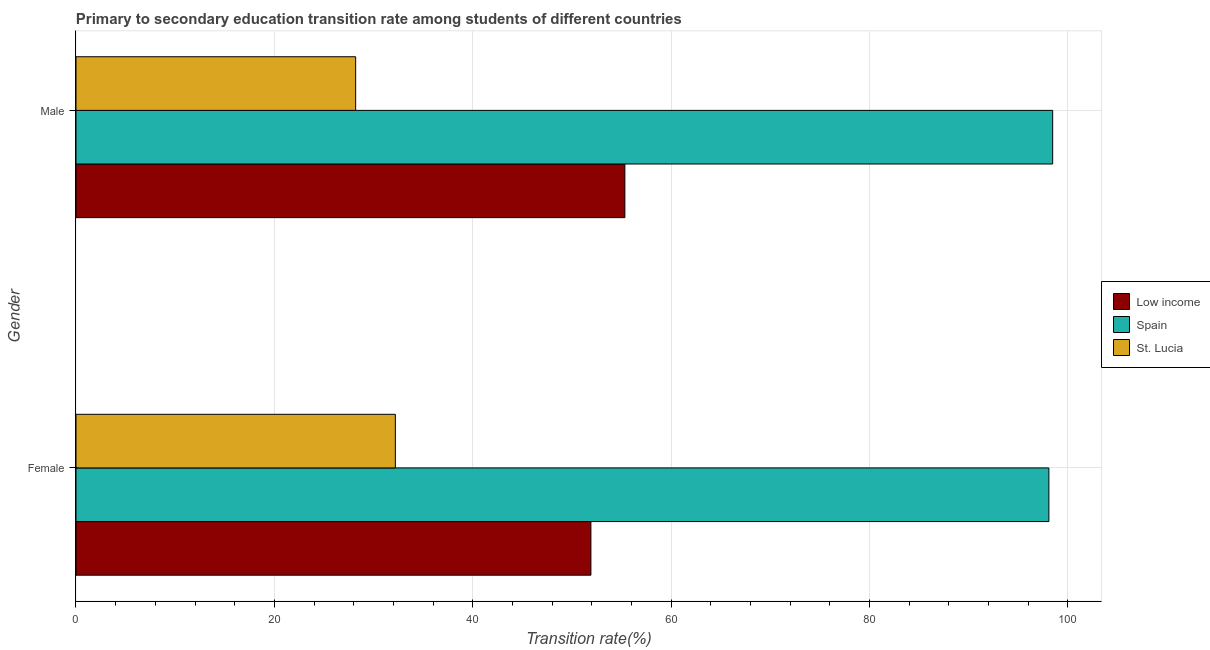How many groups of bars are there?
Keep it short and to the point. 2. Are the number of bars on each tick of the Y-axis equal?
Provide a short and direct response. Yes. How many bars are there on the 2nd tick from the bottom?
Provide a short and direct response. 3. What is the label of the 2nd group of bars from the top?
Make the answer very short. Female. What is the transition rate among female students in Low income?
Your answer should be very brief. 51.92. Across all countries, what is the maximum transition rate among male students?
Make the answer very short. 98.48. Across all countries, what is the minimum transition rate among female students?
Make the answer very short. 32.2. In which country was the transition rate among female students minimum?
Offer a terse response. St. Lucia. What is the total transition rate among male students in the graph?
Ensure brevity in your answer.  182.03. What is the difference between the transition rate among female students in Spain and that in Low income?
Your response must be concise. 46.18. What is the difference between the transition rate among male students in Spain and the transition rate among female students in Low income?
Offer a terse response. 46.56. What is the average transition rate among male students per country?
Provide a succinct answer. 60.68. What is the difference between the transition rate among female students and transition rate among male students in St. Lucia?
Provide a short and direct response. 4. In how many countries, is the transition rate among male students greater than 12 %?
Ensure brevity in your answer.  3. What is the ratio of the transition rate among male students in Spain to that in St. Lucia?
Make the answer very short. 3.49. What does the 1st bar from the top in Female represents?
Provide a succinct answer. St. Lucia. How many bars are there?
Your response must be concise. 6. Are all the bars in the graph horizontal?
Provide a succinct answer. Yes. How many countries are there in the graph?
Provide a short and direct response. 3. What is the difference between two consecutive major ticks on the X-axis?
Your answer should be compact. 20. Are the values on the major ticks of X-axis written in scientific E-notation?
Your answer should be compact. No. Does the graph contain grids?
Your answer should be compact. Yes. Where does the legend appear in the graph?
Make the answer very short. Center right. What is the title of the graph?
Your answer should be compact. Primary to secondary education transition rate among students of different countries. What is the label or title of the X-axis?
Ensure brevity in your answer.  Transition rate(%). What is the Transition rate(%) of Low income in Female?
Make the answer very short. 51.92. What is the Transition rate(%) in Spain in Female?
Make the answer very short. 98.1. What is the Transition rate(%) of St. Lucia in Female?
Offer a very short reply. 32.2. What is the Transition rate(%) of Low income in Male?
Provide a short and direct response. 55.35. What is the Transition rate(%) in Spain in Male?
Ensure brevity in your answer.  98.48. What is the Transition rate(%) in St. Lucia in Male?
Make the answer very short. 28.2. Across all Gender, what is the maximum Transition rate(%) of Low income?
Keep it short and to the point. 55.35. Across all Gender, what is the maximum Transition rate(%) of Spain?
Give a very brief answer. 98.48. Across all Gender, what is the maximum Transition rate(%) in St. Lucia?
Your response must be concise. 32.2. Across all Gender, what is the minimum Transition rate(%) of Low income?
Your answer should be very brief. 51.92. Across all Gender, what is the minimum Transition rate(%) in Spain?
Offer a terse response. 98.1. Across all Gender, what is the minimum Transition rate(%) in St. Lucia?
Your answer should be very brief. 28.2. What is the total Transition rate(%) of Low income in the graph?
Ensure brevity in your answer.  107.27. What is the total Transition rate(%) in Spain in the graph?
Keep it short and to the point. 196.58. What is the total Transition rate(%) in St. Lucia in the graph?
Keep it short and to the point. 60.4. What is the difference between the Transition rate(%) of Low income in Female and that in Male?
Ensure brevity in your answer.  -3.42. What is the difference between the Transition rate(%) of Spain in Female and that in Male?
Provide a short and direct response. -0.38. What is the difference between the Transition rate(%) of St. Lucia in Female and that in Male?
Provide a short and direct response. 4. What is the difference between the Transition rate(%) in Low income in Female and the Transition rate(%) in Spain in Male?
Offer a terse response. -46.56. What is the difference between the Transition rate(%) of Low income in Female and the Transition rate(%) of St. Lucia in Male?
Offer a terse response. 23.72. What is the difference between the Transition rate(%) of Spain in Female and the Transition rate(%) of St. Lucia in Male?
Your response must be concise. 69.9. What is the average Transition rate(%) in Low income per Gender?
Provide a succinct answer. 53.63. What is the average Transition rate(%) of Spain per Gender?
Make the answer very short. 98.29. What is the average Transition rate(%) in St. Lucia per Gender?
Keep it short and to the point. 30.2. What is the difference between the Transition rate(%) in Low income and Transition rate(%) in Spain in Female?
Provide a short and direct response. -46.18. What is the difference between the Transition rate(%) in Low income and Transition rate(%) in St. Lucia in Female?
Provide a short and direct response. 19.72. What is the difference between the Transition rate(%) in Spain and Transition rate(%) in St. Lucia in Female?
Make the answer very short. 65.9. What is the difference between the Transition rate(%) of Low income and Transition rate(%) of Spain in Male?
Give a very brief answer. -43.13. What is the difference between the Transition rate(%) in Low income and Transition rate(%) in St. Lucia in Male?
Your answer should be very brief. 27.15. What is the difference between the Transition rate(%) of Spain and Transition rate(%) of St. Lucia in Male?
Give a very brief answer. 70.28. What is the ratio of the Transition rate(%) of Low income in Female to that in Male?
Your answer should be very brief. 0.94. What is the ratio of the Transition rate(%) of Spain in Female to that in Male?
Provide a succinct answer. 1. What is the ratio of the Transition rate(%) of St. Lucia in Female to that in Male?
Keep it short and to the point. 1.14. What is the difference between the highest and the second highest Transition rate(%) in Low income?
Your response must be concise. 3.42. What is the difference between the highest and the second highest Transition rate(%) in Spain?
Offer a terse response. 0.38. What is the difference between the highest and the second highest Transition rate(%) in St. Lucia?
Ensure brevity in your answer.  4. What is the difference between the highest and the lowest Transition rate(%) in Low income?
Provide a short and direct response. 3.42. What is the difference between the highest and the lowest Transition rate(%) of Spain?
Offer a very short reply. 0.38. What is the difference between the highest and the lowest Transition rate(%) in St. Lucia?
Keep it short and to the point. 4. 